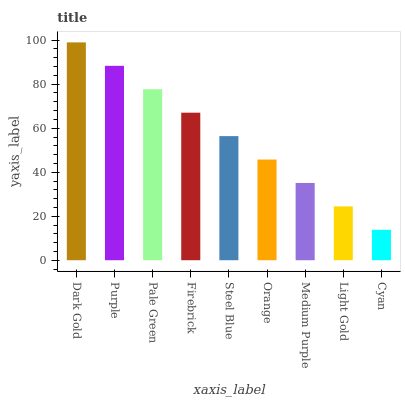Is Cyan the minimum?
Answer yes or no. Yes. Is Dark Gold the maximum?
Answer yes or no. Yes. Is Purple the minimum?
Answer yes or no. No. Is Purple the maximum?
Answer yes or no. No. Is Dark Gold greater than Purple?
Answer yes or no. Yes. Is Purple less than Dark Gold?
Answer yes or no. Yes. Is Purple greater than Dark Gold?
Answer yes or no. No. Is Dark Gold less than Purple?
Answer yes or no. No. Is Steel Blue the high median?
Answer yes or no. Yes. Is Steel Blue the low median?
Answer yes or no. Yes. Is Pale Green the high median?
Answer yes or no. No. Is Cyan the low median?
Answer yes or no. No. 